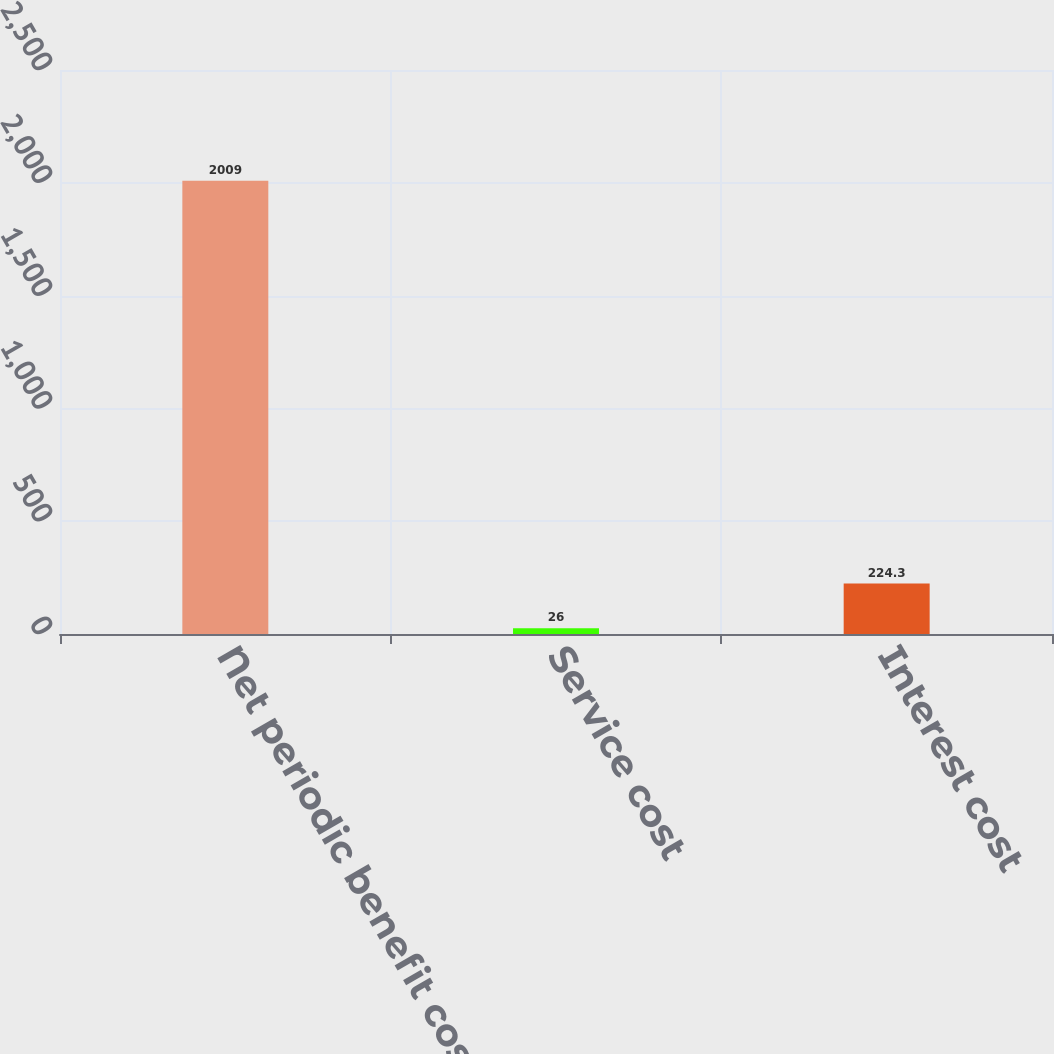Convert chart. <chart><loc_0><loc_0><loc_500><loc_500><bar_chart><fcel>Net periodic benefit cost<fcel>Service cost<fcel>Interest cost<nl><fcel>2009<fcel>26<fcel>224.3<nl></chart> 